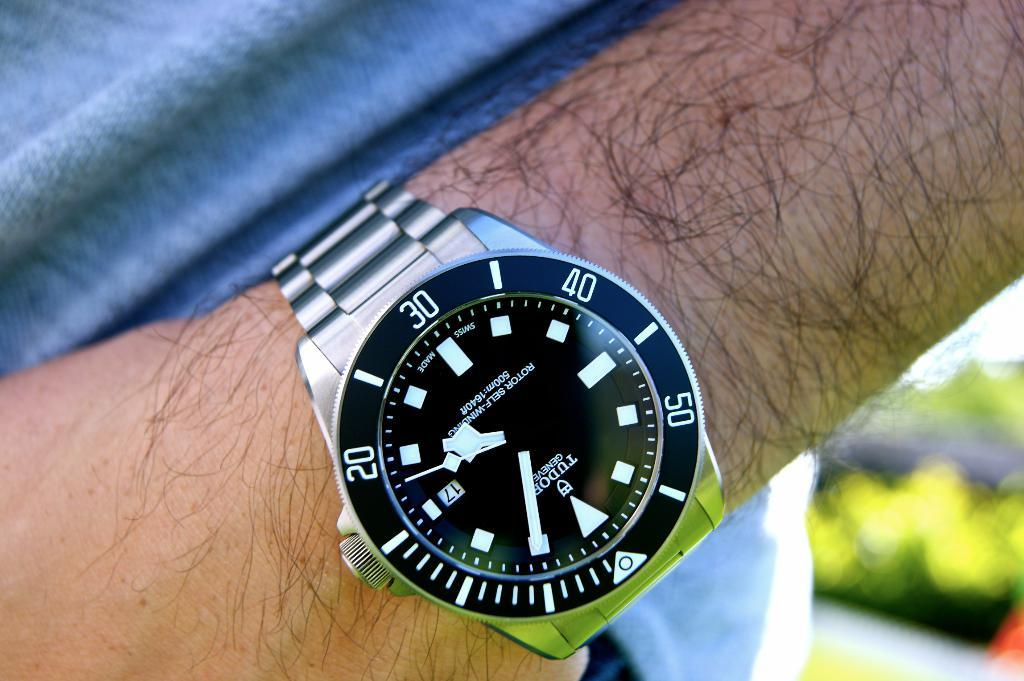<image>
Describe the image concisely. A Tudor Geneva watch on a hairy man's wrist. 